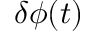Convert formula to latex. <formula><loc_0><loc_0><loc_500><loc_500>\delta \phi ( t )</formula> 